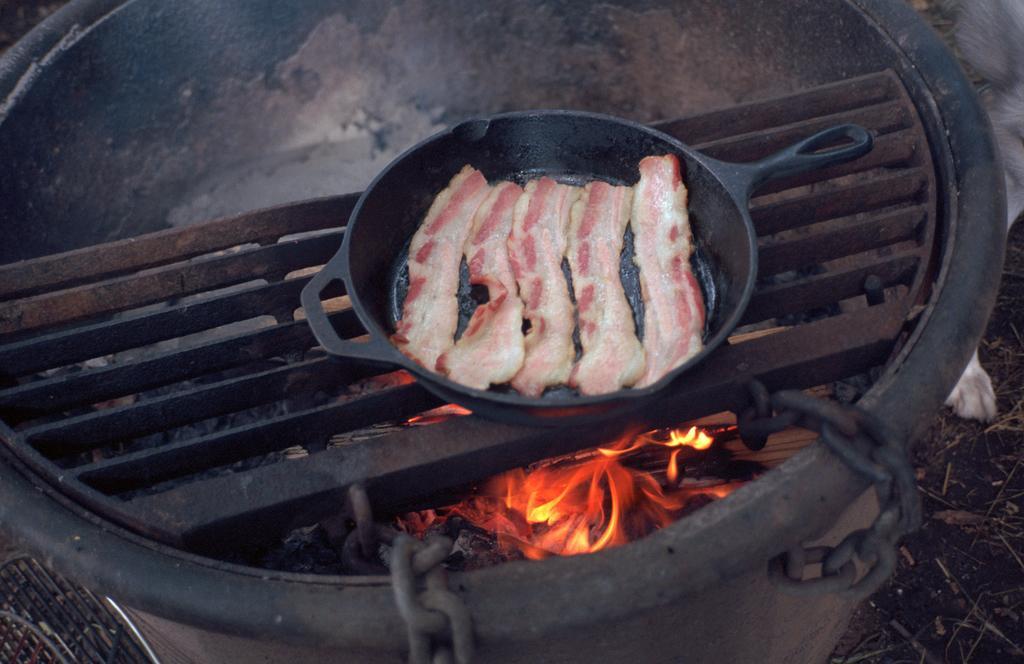Describe this image in one or two sentences. In this image there is a food on the fire. 